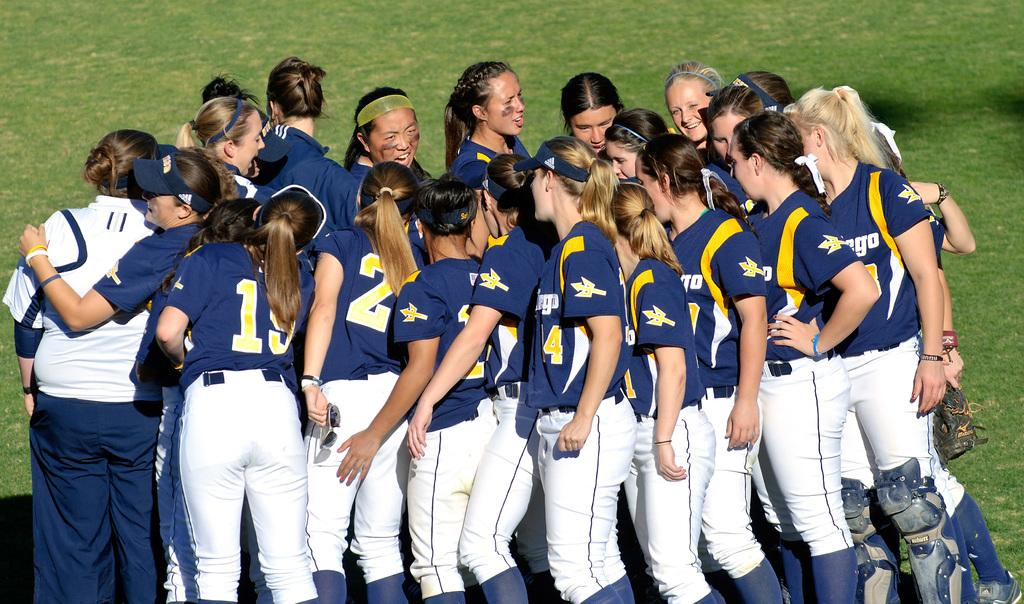<image>
Describe the image concisely. the team including number 19 and number 2 are standing in a circle 